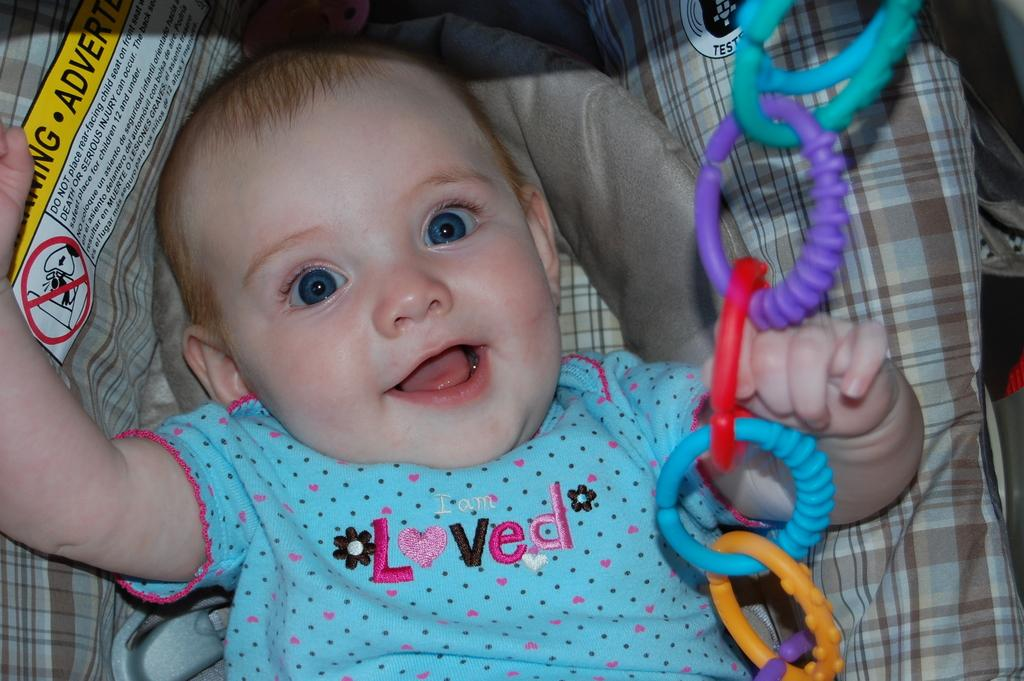What is the main subject of the picture? The main subject of the picture is a baby. What objects are present in the picture besides the baby? There are plastic rings in the picture. What type of wood can be seen in the picture? There is no wood present in the picture; it features a baby and plastic rings. What sound can be heard in the picture due to the thunder? There is no thunder present in the picture, so no sound can be heard. 